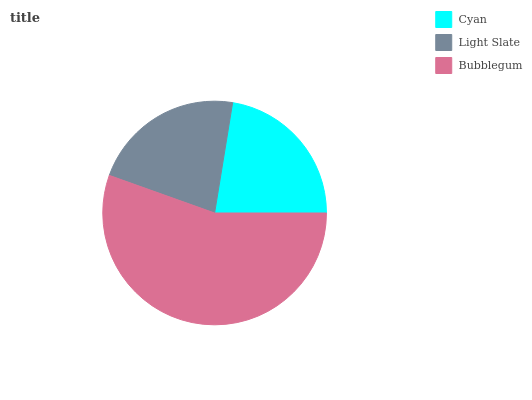Is Light Slate the minimum?
Answer yes or no. Yes. Is Bubblegum the maximum?
Answer yes or no. Yes. Is Bubblegum the minimum?
Answer yes or no. No. Is Light Slate the maximum?
Answer yes or no. No. Is Bubblegum greater than Light Slate?
Answer yes or no. Yes. Is Light Slate less than Bubblegum?
Answer yes or no. Yes. Is Light Slate greater than Bubblegum?
Answer yes or no. No. Is Bubblegum less than Light Slate?
Answer yes or no. No. Is Cyan the high median?
Answer yes or no. Yes. Is Cyan the low median?
Answer yes or no. Yes. Is Light Slate the high median?
Answer yes or no. No. Is Light Slate the low median?
Answer yes or no. No. 